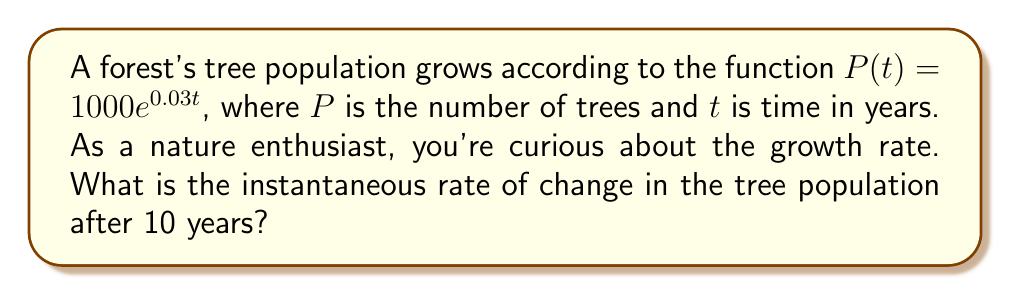Could you help me with this problem? To find the instantaneous rate of change, we need to find the derivative of $P(t)$ and evaluate it at $t=10$.

Step 1: Find the derivative of $P(t)$.
$$\frac{d}{dt}P(t) = \frac{d}{dt}(1000e^{0.03t})$$
Using the chain rule:
$$P'(t) = 1000 \cdot 0.03 \cdot e^{0.03t}$$
$$P'(t) = 30e^{0.03t}$$

Step 2: Evaluate $P'(t)$ at $t=10$.
$$P'(10) = 30e^{0.03 \cdot 10}$$
$$P'(10) = 30e^{0.3}$$
$$P'(10) \approx 40.34$$

Therefore, after 10 years, the instantaneous rate of change in the tree population is approximately 40.34 trees per year.
Answer: $40.34$ trees/year 